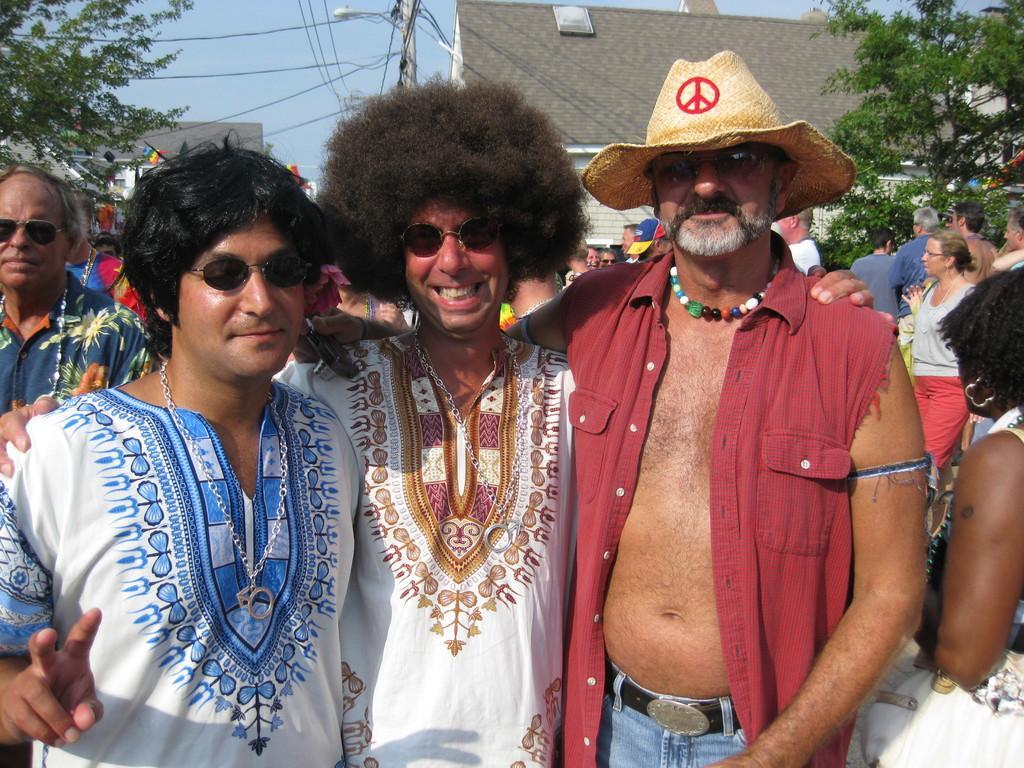Please provide a concise description of this image. In this image I can see three men are standing, smiling and giving pose for the picture. In the background there are some more people and buildings. On the top of the image I can see a pole, wires and the sky. On right and left side of the image I can see the trees. 